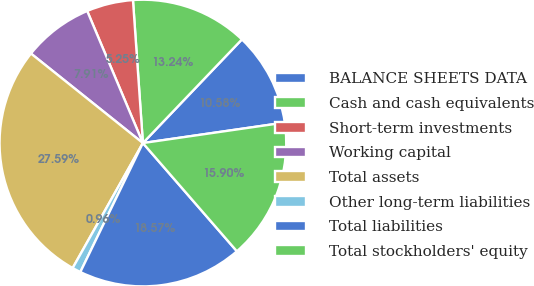<chart> <loc_0><loc_0><loc_500><loc_500><pie_chart><fcel>BALANCE SHEETS DATA<fcel>Cash and cash equivalents<fcel>Short-term investments<fcel>Working capital<fcel>Total assets<fcel>Other long-term liabilities<fcel>Total liabilities<fcel>Total stockholders' equity<nl><fcel>10.58%<fcel>13.24%<fcel>5.25%<fcel>7.91%<fcel>27.59%<fcel>0.96%<fcel>18.57%<fcel>15.9%<nl></chart> 